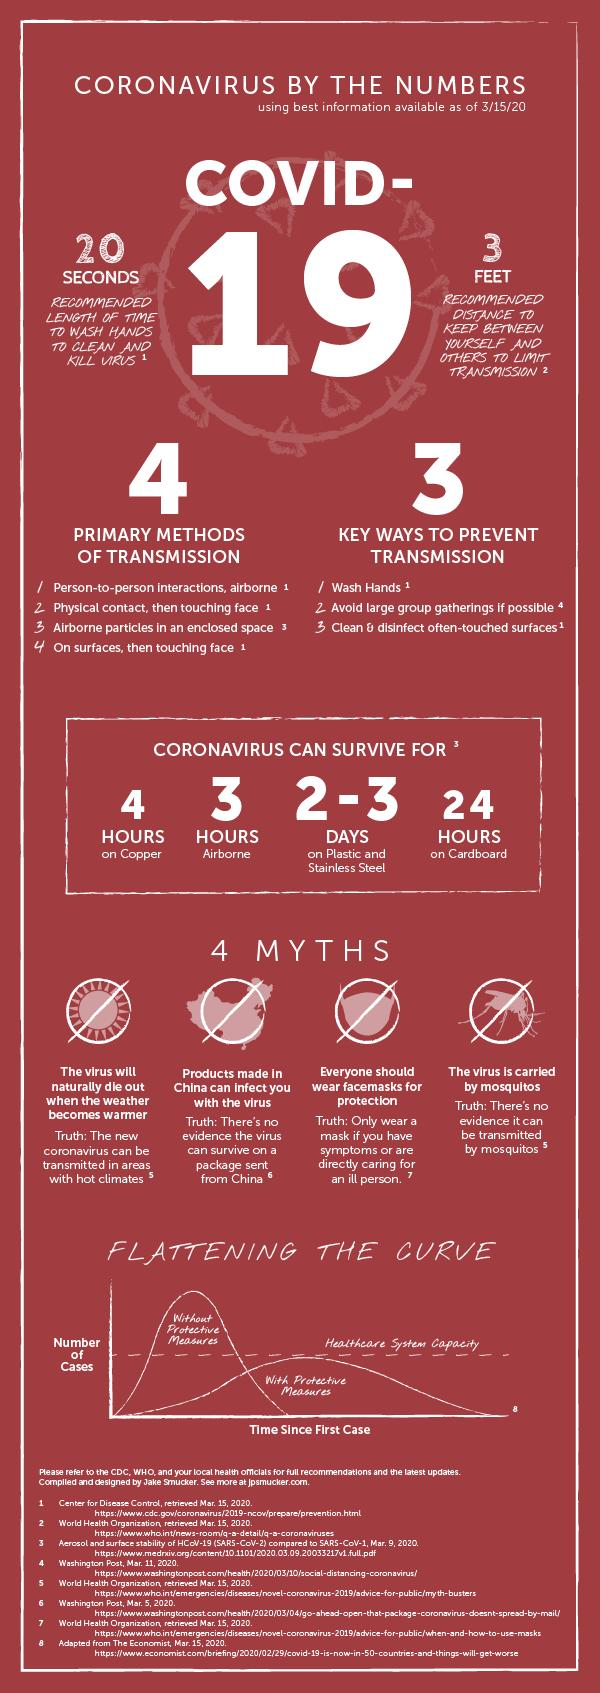Outline some significant characteristics in this image. The corona virus can survive on cardboard for one day. 